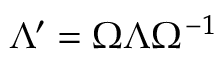Convert formula to latex. <formula><loc_0><loc_0><loc_500><loc_500>\Lambda ^ { \prime } = \Omega \Lambda \Omega ^ { - 1 }</formula> 